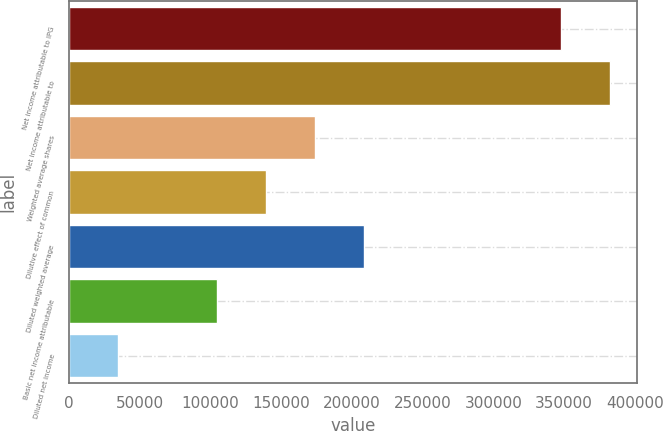Convert chart to OTSL. <chart><loc_0><loc_0><loc_500><loc_500><bar_chart><fcel>Net income attributable to IPG<fcel>Net income attributable to<fcel>Weighted average shares<fcel>Dilutive effect of common<fcel>Diluted weighted average<fcel>Basic net income attributable<fcel>Diluted net income<nl><fcel>347614<fcel>382375<fcel>173810<fcel>139049<fcel>208571<fcel>104289<fcel>34767.1<nl></chart> 